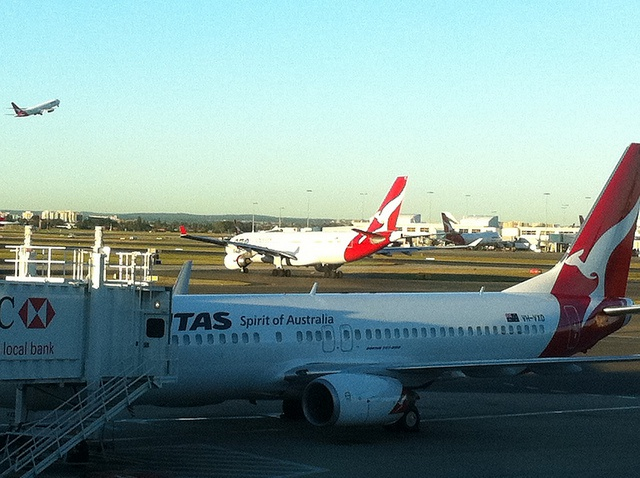Describe the objects in this image and their specific colors. I can see airplane in lightblue, blue, black, teal, and darkgray tones, airplane in lightblue, ivory, red, gray, and black tones, airplane in lightblue, gray, ivory, and black tones, airplane in lightblue, beige, gray, and darkgray tones, and airplane in lightblue, white, gray, and darkgray tones in this image. 